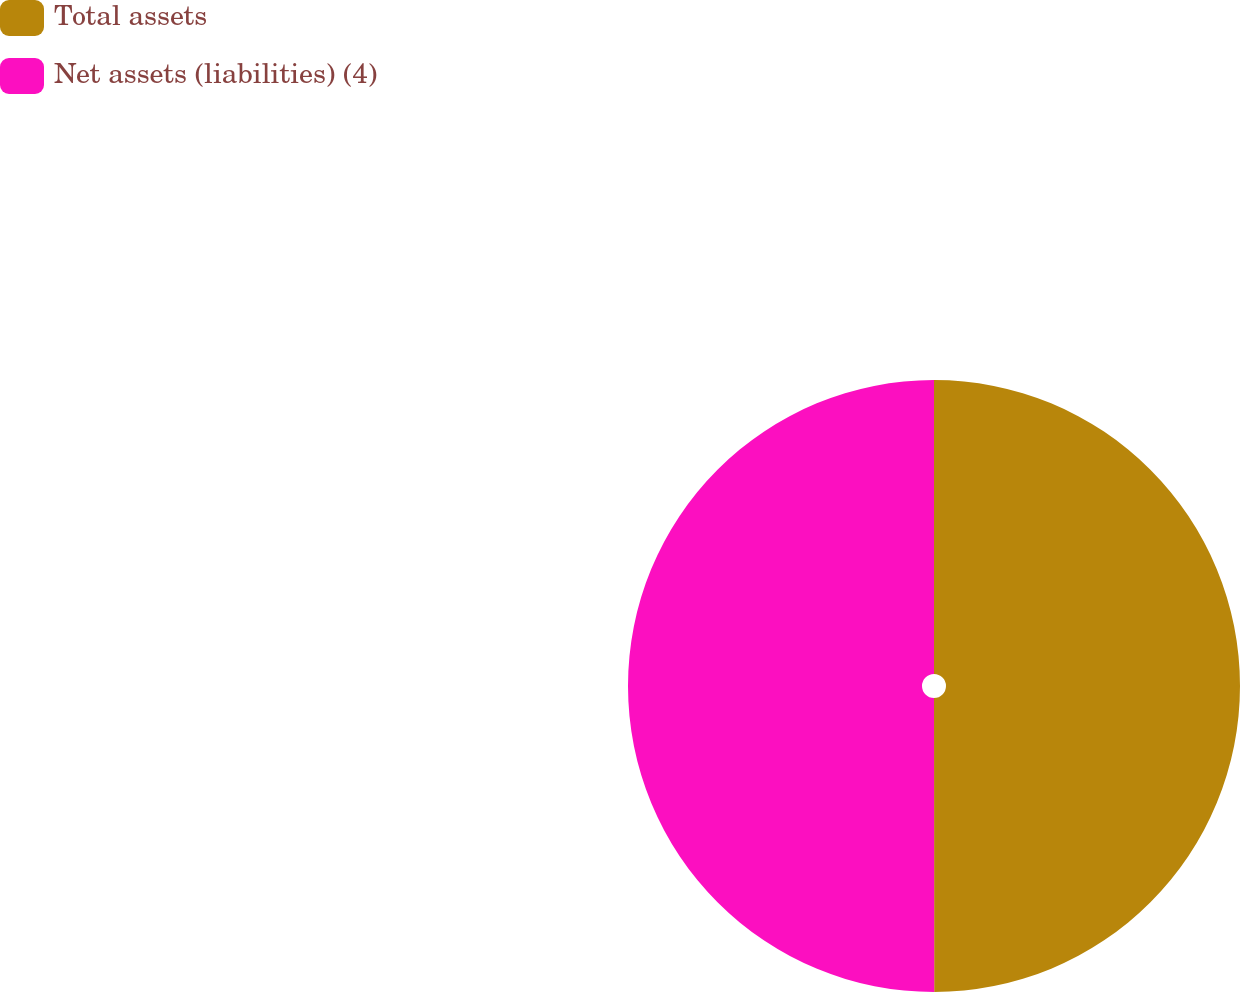<chart> <loc_0><loc_0><loc_500><loc_500><pie_chart><fcel>Total assets<fcel>Net assets (liabilities) (4)<nl><fcel>49.99%<fcel>50.01%<nl></chart> 